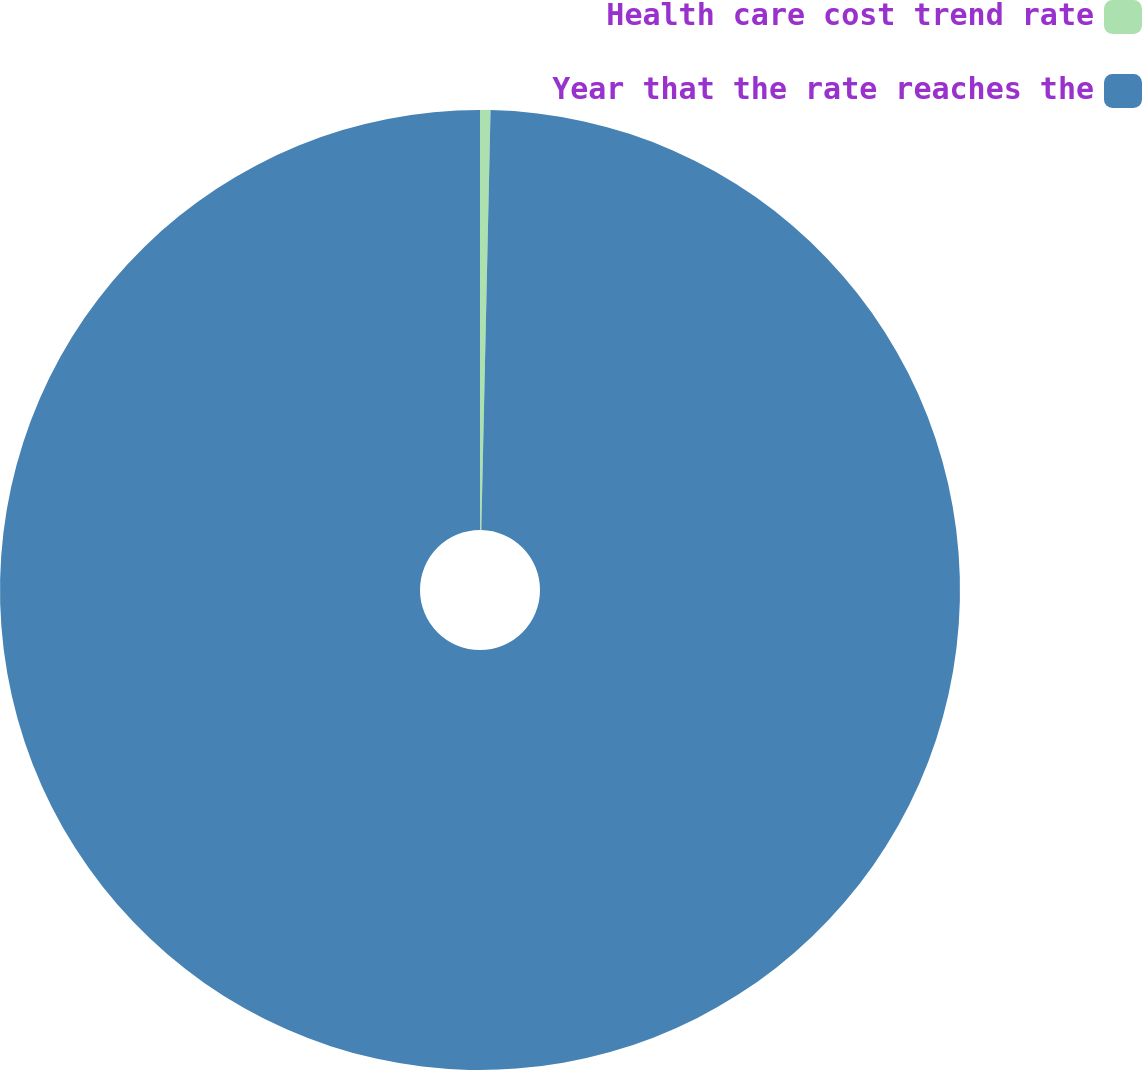Convert chart. <chart><loc_0><loc_0><loc_500><loc_500><pie_chart><fcel>Health care cost trend rate<fcel>Year that the rate reaches the<nl><fcel>0.35%<fcel>99.65%<nl></chart> 